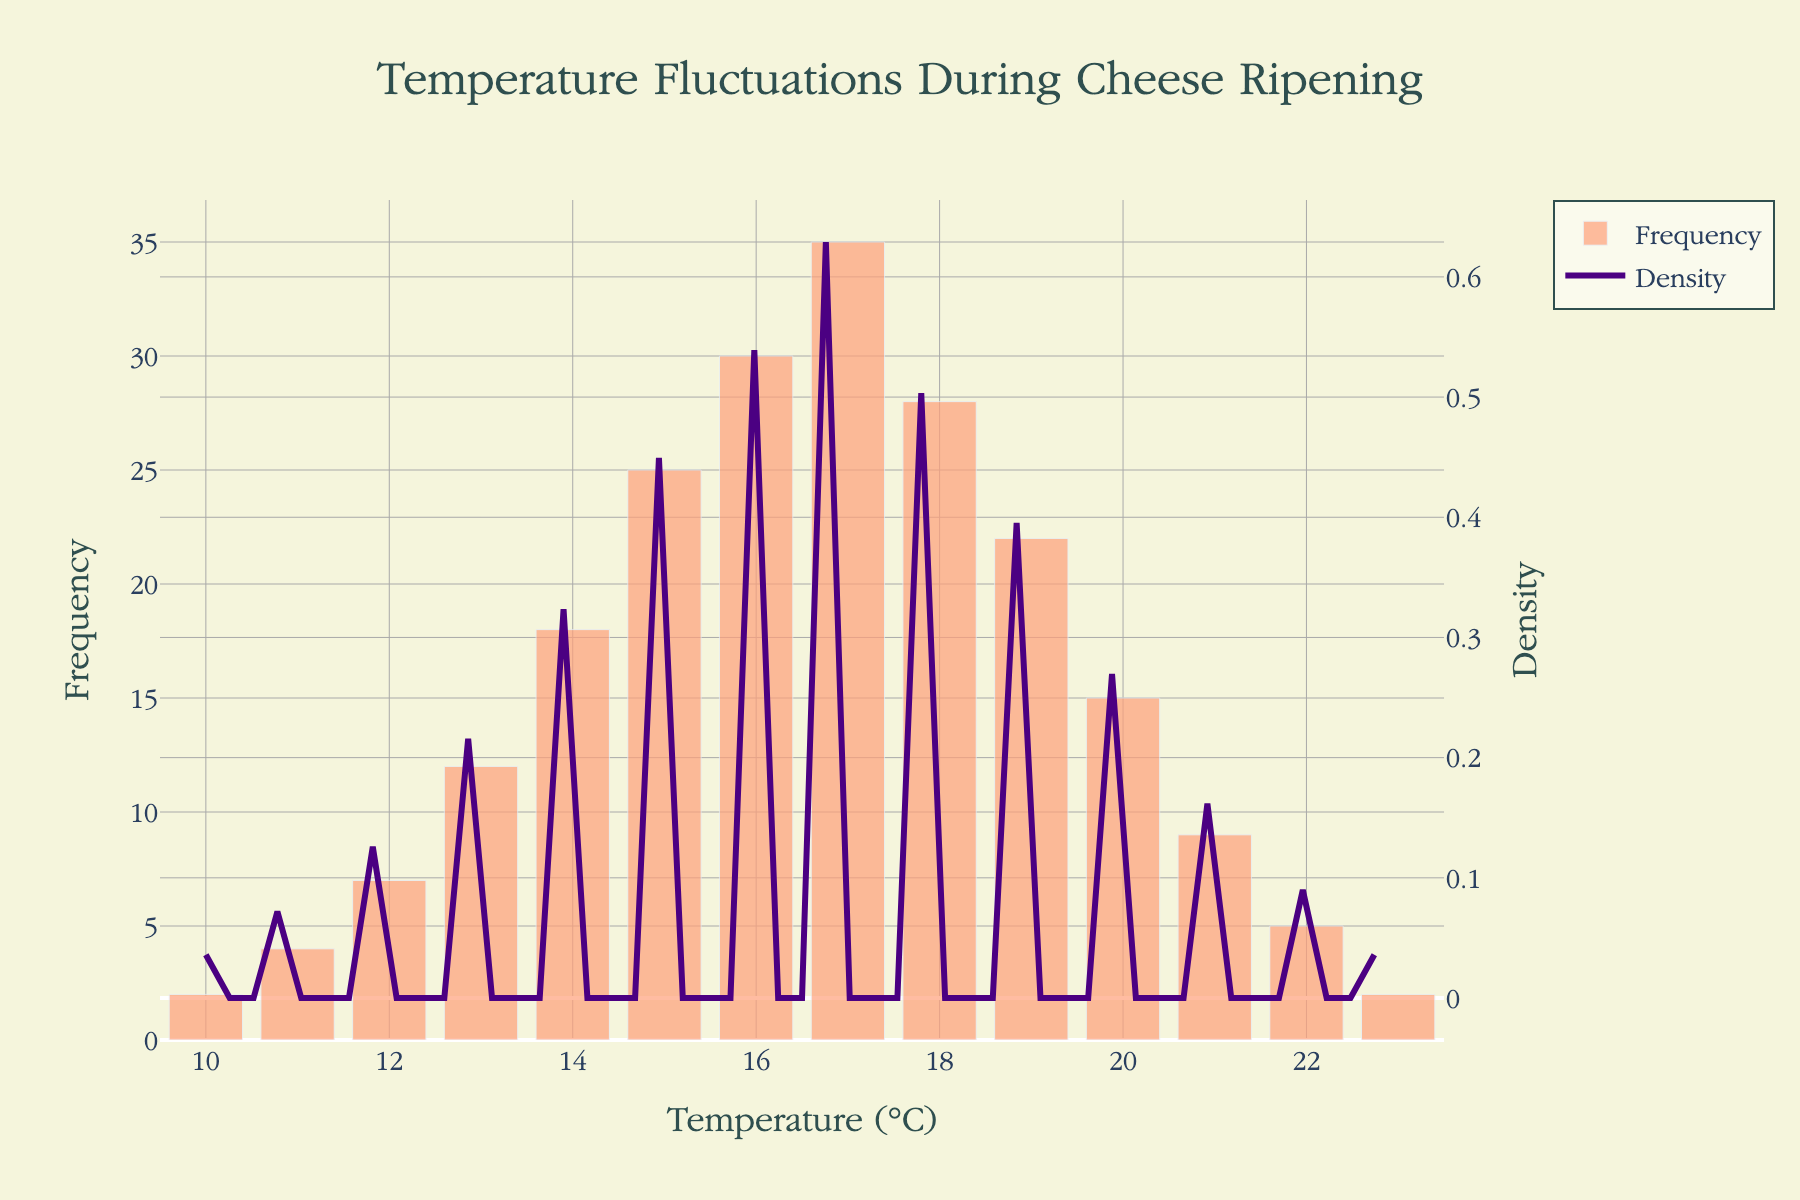What's the title of the figure? The title is usually displayed at the top of the figure. In this case, it reads "Temperature Fluctuations During Cheese Ripening".
Answer: Temperature Fluctuations During Cheese Ripening What is the temperature range covered in the histogram? By observing the x-axis, you can see that the temperature values range from 10°C to 23°C.
Answer: 10°C to 23°C What is the most frequent temperature observed in the data? The highest bar in the histogram represents the most frequent temperature. The bar at 17°C is the highest.
Answer: 17°C At what temperature does the frequency begin to drop significantly? The frequency of observed temperatures starts to significantly drop after the peak at 17°C. Therefore, it begins to drop noticeably from 18°C onwards.
Answer: 18°C Which temperature has the highest density according to the KDE curve? The KDE curve peaks at the temperature where the density is highest. The highest point on the density curve is around 17°C.
Answer: 17°C How many temperature points have a frequency greater than or equal to 20? Counting the bars in the histogram that have a frequency at or above 20, there are 4 bars at temperatures 16°C, 17°C, 18°C, and 19°C.
Answer: 4 What is the total frequency of temperatures from 10°C to 15°C? Add the frequencies for temperatures 10, 11, 12, 13, 14, and 15: 2 + 4 + 7 + 12 + 18 + 25 = 68.
Answer: 68 How does the density of 19°C compare to that of 16°C? Observing the density curve, we see that the density at 16°C is higher than at 19°C.
Answer: Higher at 16°C Is the temperature distribution symmetric? By comparing both sides of the histogram around the peak at 17°C, it is noticeable that the distribution tails off more rapidly on the higher temperature side than the lower side. Hence, it is not symmetric.
Answer: No How would you describe the overall shape of the temperature distribution? The histogram and KDE curve reveal that the distribution is unimodal with a right-skewed shape, meaning it has a single peak around 17°C and a longer tail towards higher temperatures.
Answer: Unimodal and right-skewed Which has a larger frequency difference, between 12°C and 14°C or between 20°C and 22°C? Calculate the differences: For 12°C and 14°C, the frequencies are 7 and 18, giving a difference of 18 - 7 = 11. For 20°C and 22°C, the frequencies are 15 and 5, giving a difference of 15 - 5 = 10.
Answer: 12°C and 14°C 